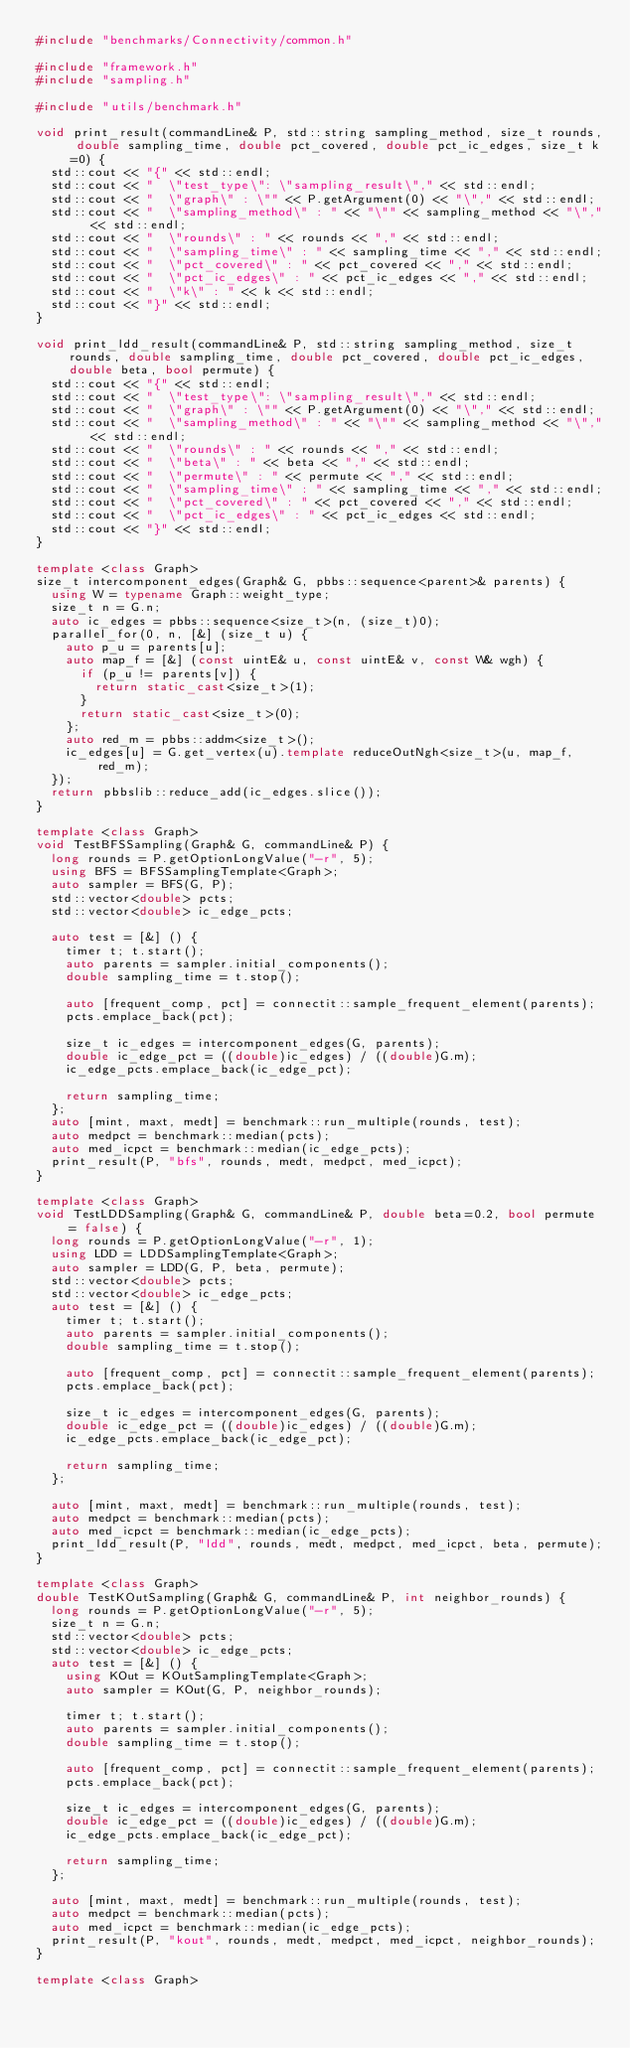<code> <loc_0><loc_0><loc_500><loc_500><_C++_>#include "benchmarks/Connectivity/common.h"

#include "framework.h"
#include "sampling.h"

#include "utils/benchmark.h"

void print_result(commandLine& P, std::string sampling_method, size_t rounds, double sampling_time, double pct_covered, double pct_ic_edges, size_t k=0) {
  std::cout << "{" << std::endl;
  std::cout << "  \"test_type\": \"sampling_result\"," << std::endl;
  std::cout << "  \"graph\" : \"" << P.getArgument(0) << "\"," << std::endl;
  std::cout << "  \"sampling_method\" : " << "\"" << sampling_method << "\"," << std::endl;
  std::cout << "  \"rounds\" : " << rounds << "," << std::endl;
  std::cout << "  \"sampling_time\" : " << sampling_time << "," << std::endl;
  std::cout << "  \"pct_covered\" : " << pct_covered << "," << std::endl;
  std::cout << "  \"pct_ic_edges\" : " << pct_ic_edges << "," << std::endl;
  std::cout << "  \"k\" : " << k << std::endl;
  std::cout << "}" << std::endl;
}

void print_ldd_result(commandLine& P, std::string sampling_method, size_t rounds, double sampling_time, double pct_covered, double pct_ic_edges, double beta, bool permute) {
  std::cout << "{" << std::endl;
  std::cout << "  \"test_type\": \"sampling_result\"," << std::endl;
  std::cout << "  \"graph\" : \"" << P.getArgument(0) << "\"," << std::endl;
  std::cout << "  \"sampling_method\" : " << "\"" << sampling_method << "\"," << std::endl;
  std::cout << "  \"rounds\" : " << rounds << "," << std::endl;
  std::cout << "  \"beta\" : " << beta << "," << std::endl;
  std::cout << "  \"permute\" : " << permute << "," << std::endl;
  std::cout << "  \"sampling_time\" : " << sampling_time << "," << std::endl;
  std::cout << "  \"pct_covered\" : " << pct_covered << "," << std::endl;
  std::cout << "  \"pct_ic_edges\" : " << pct_ic_edges << std::endl;
  std::cout << "}" << std::endl;
}

template <class Graph>
size_t intercomponent_edges(Graph& G, pbbs::sequence<parent>& parents) {
  using W = typename Graph::weight_type;
  size_t n = G.n;
  auto ic_edges = pbbs::sequence<size_t>(n, (size_t)0);
  parallel_for(0, n, [&] (size_t u) {
    auto p_u = parents[u];
    auto map_f = [&] (const uintE& u, const uintE& v, const W& wgh) {
      if (p_u != parents[v]) {
        return static_cast<size_t>(1);
      }
      return static_cast<size_t>(0);
    };
    auto red_m = pbbs::addm<size_t>();
    ic_edges[u] = G.get_vertex(u).template reduceOutNgh<size_t>(u, map_f, red_m);
  });
  return pbbslib::reduce_add(ic_edges.slice());
}

template <class Graph>
void TestBFSSampling(Graph& G, commandLine& P) {
  long rounds = P.getOptionLongValue("-r", 5);
  using BFS = BFSSamplingTemplate<Graph>;
  auto sampler = BFS(G, P);
  std::vector<double> pcts;
  std::vector<double> ic_edge_pcts;

  auto test = [&] () {
    timer t; t.start();
    auto parents = sampler.initial_components();
    double sampling_time = t.stop();

    auto [frequent_comp, pct] = connectit::sample_frequent_element(parents);
    pcts.emplace_back(pct);

    size_t ic_edges = intercomponent_edges(G, parents);
    double ic_edge_pct = ((double)ic_edges) / ((double)G.m);
    ic_edge_pcts.emplace_back(ic_edge_pct);

    return sampling_time;
  };
  auto [mint, maxt, medt] = benchmark::run_multiple(rounds, test);
  auto medpct = benchmark::median(pcts);
  auto med_icpct = benchmark::median(ic_edge_pcts);
  print_result(P, "bfs", rounds, medt, medpct, med_icpct);
}

template <class Graph>
void TestLDDSampling(Graph& G, commandLine& P, double beta=0.2, bool permute = false) {
  long rounds = P.getOptionLongValue("-r", 1);
  using LDD = LDDSamplingTemplate<Graph>;
  auto sampler = LDD(G, P, beta, permute);
  std::vector<double> pcts;
  std::vector<double> ic_edge_pcts;
  auto test = [&] () {
    timer t; t.start();
    auto parents = sampler.initial_components();
    double sampling_time = t.stop();

    auto [frequent_comp, pct] = connectit::sample_frequent_element(parents);
    pcts.emplace_back(pct);

    size_t ic_edges = intercomponent_edges(G, parents);
    double ic_edge_pct = ((double)ic_edges) / ((double)G.m);
    ic_edge_pcts.emplace_back(ic_edge_pct);

    return sampling_time;
  };

  auto [mint, maxt, medt] = benchmark::run_multiple(rounds, test);
  auto medpct = benchmark::median(pcts);
  auto med_icpct = benchmark::median(ic_edge_pcts);
  print_ldd_result(P, "ldd", rounds, medt, medpct, med_icpct, beta, permute);
}

template <class Graph>
double TestKOutSampling(Graph& G, commandLine& P, int neighbor_rounds) {
  long rounds = P.getOptionLongValue("-r", 5);
  size_t n = G.n;
  std::vector<double> pcts;
  std::vector<double> ic_edge_pcts;
  auto test = [&] () {
    using KOut = KOutSamplingTemplate<Graph>;
    auto sampler = KOut(G, P, neighbor_rounds);

    timer t; t.start();
    auto parents = sampler.initial_components();
    double sampling_time = t.stop();

    auto [frequent_comp, pct] = connectit::sample_frequent_element(parents);
    pcts.emplace_back(pct);

    size_t ic_edges = intercomponent_edges(G, parents);
    double ic_edge_pct = ((double)ic_edges) / ((double)G.m);
    ic_edge_pcts.emplace_back(ic_edge_pct);

    return sampling_time;
  };

  auto [mint, maxt, medt] = benchmark::run_multiple(rounds, test);
  auto medpct = benchmark::median(pcts);
  auto med_icpct = benchmark::median(ic_edge_pcts);
  print_result(P, "kout", rounds, medt, medpct, med_icpct, neighbor_rounds);
}

template <class Graph></code> 